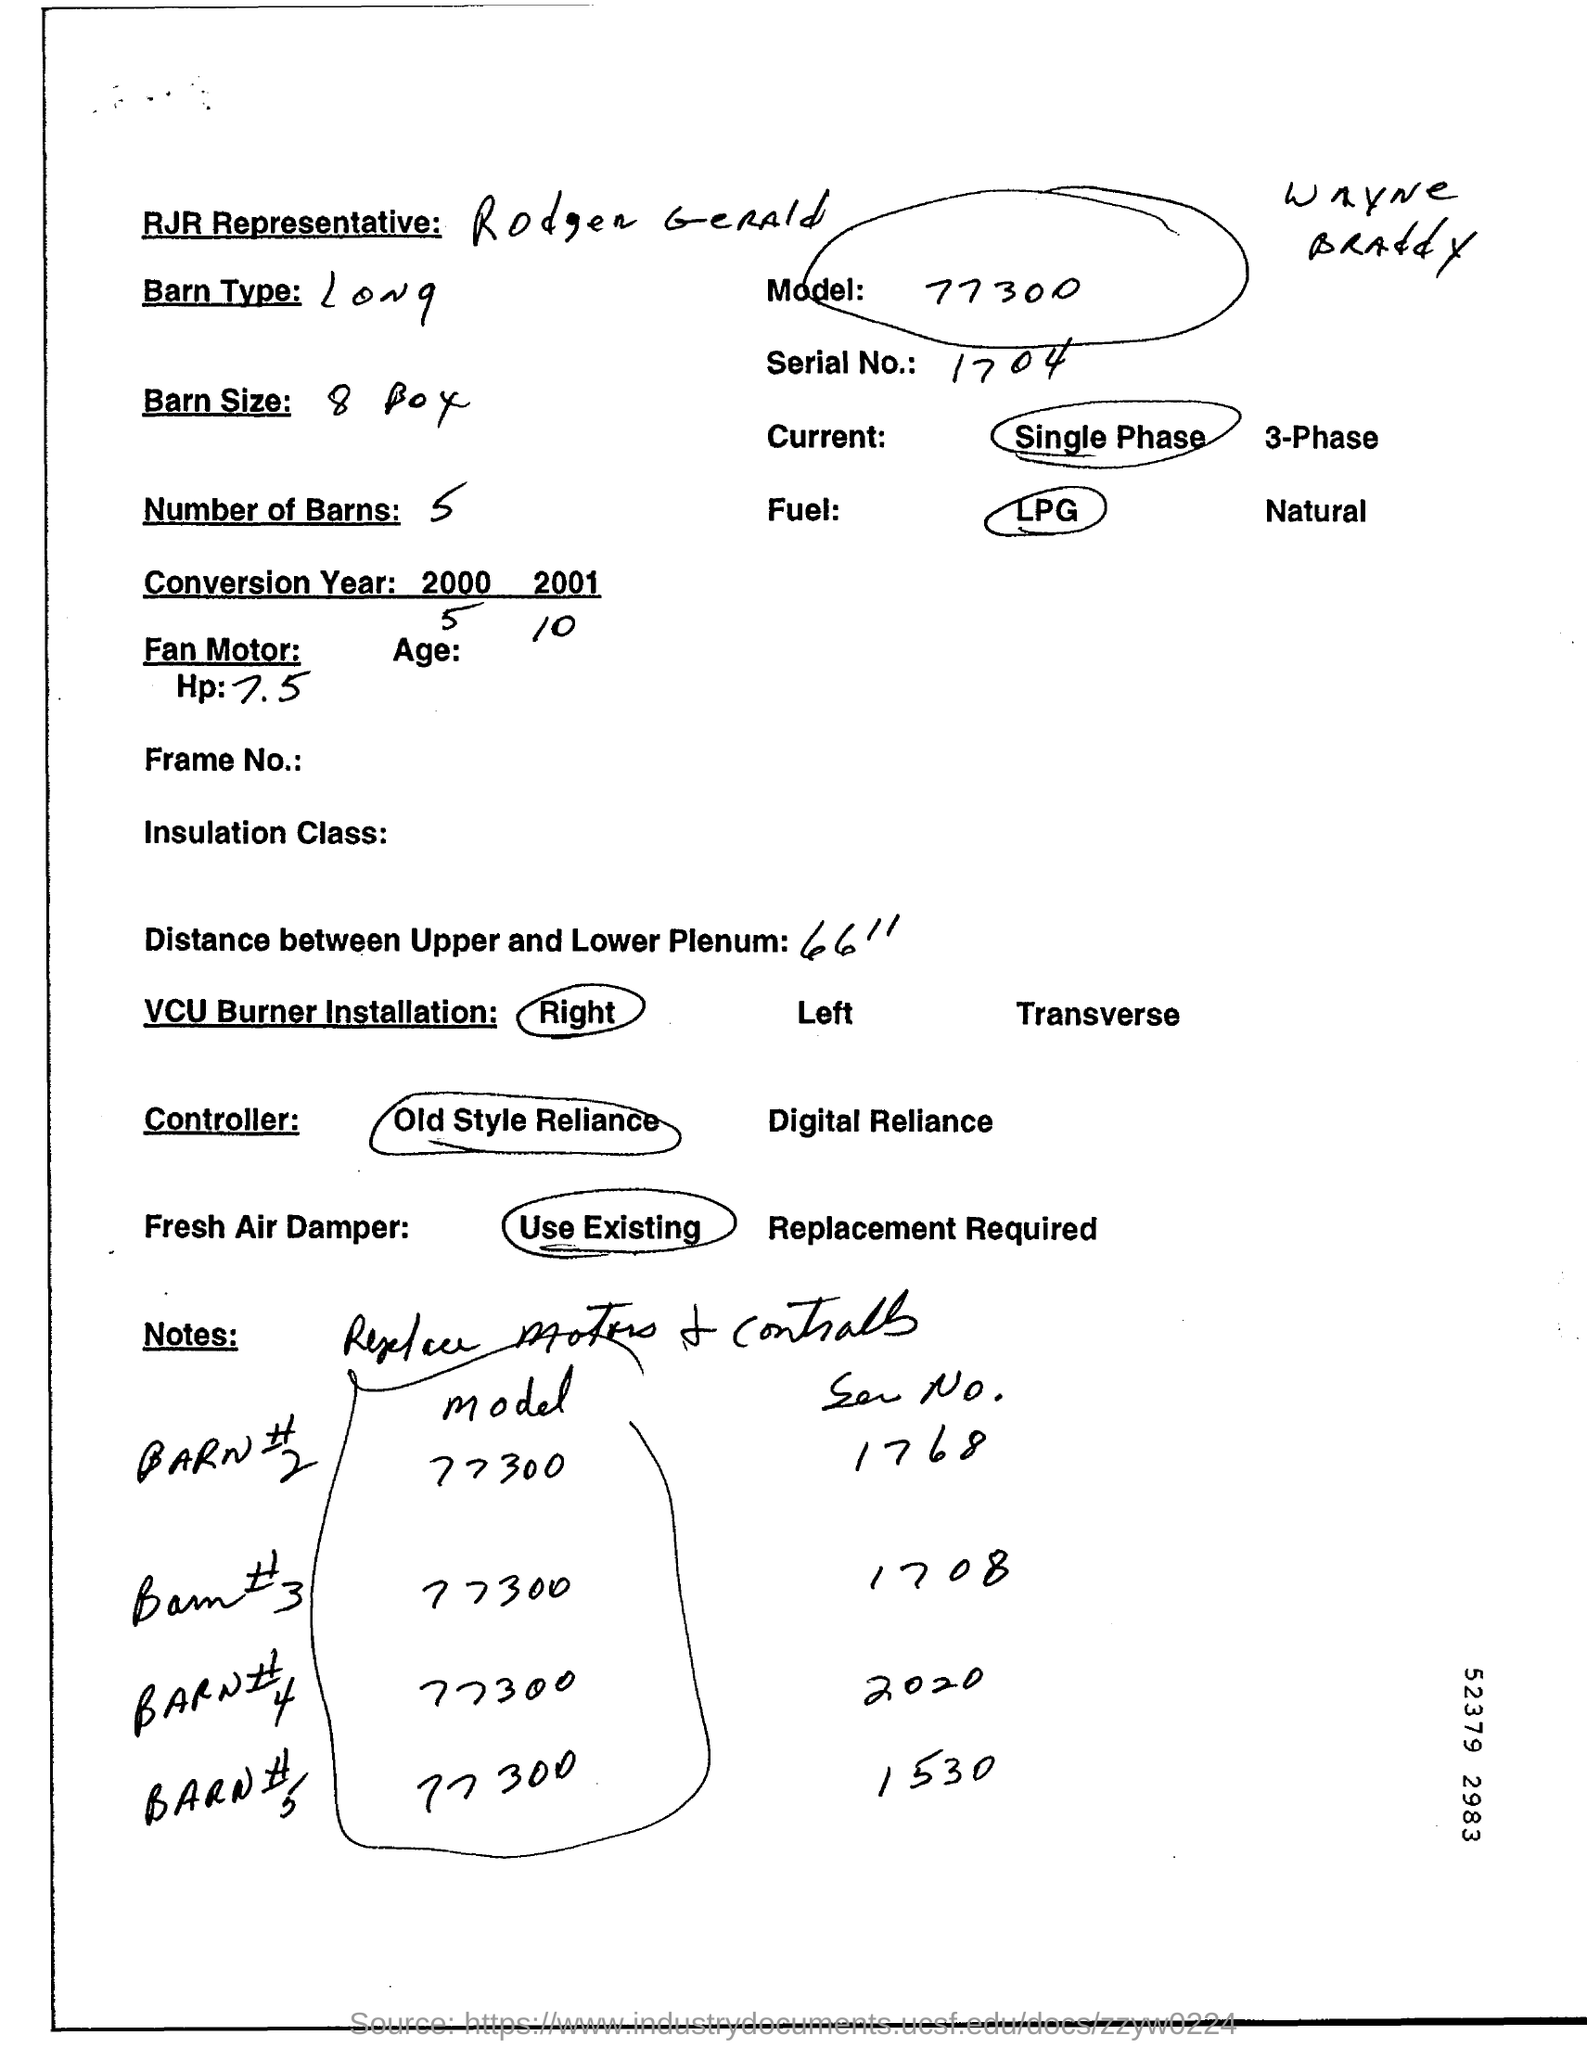Who is the RJR Representative?
Keep it short and to the point. Rodger Gerald. What is the "Serial No."?
Provide a succinct answer. 1704. What is the distance between Upper and Lower Plenum?
Give a very brief answer. 66". 